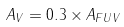<formula> <loc_0><loc_0><loc_500><loc_500>A _ { V } = 0 . 3 \times A _ { F U V }</formula> 